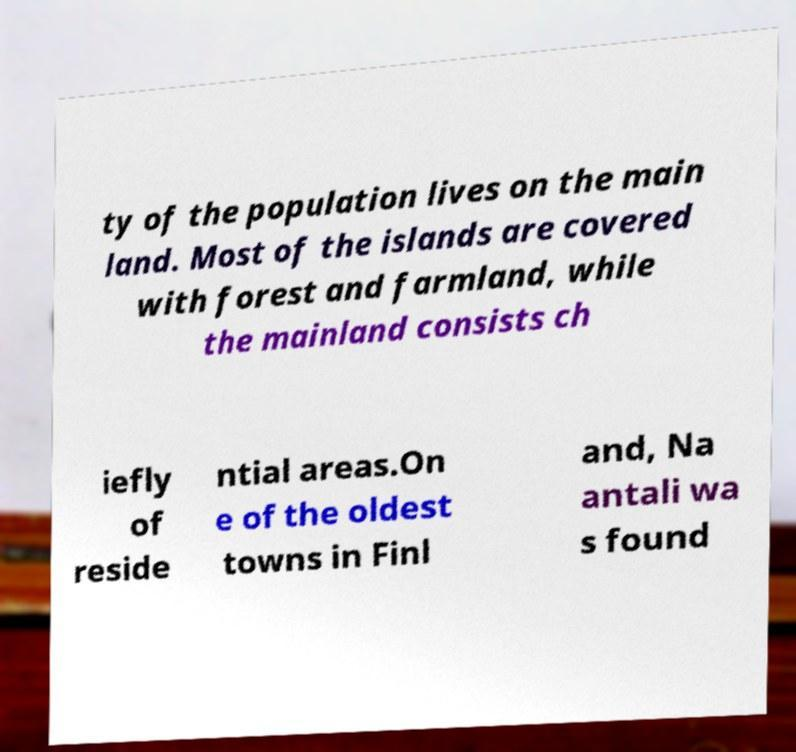Could you extract and type out the text from this image? ty of the population lives on the main land. Most of the islands are covered with forest and farmland, while the mainland consists ch iefly of reside ntial areas.On e of the oldest towns in Finl and, Na antali wa s found 